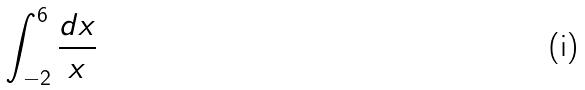Convert formula to latex. <formula><loc_0><loc_0><loc_500><loc_500>\int _ { - 2 } ^ { 6 } \frac { d x } { x }</formula> 